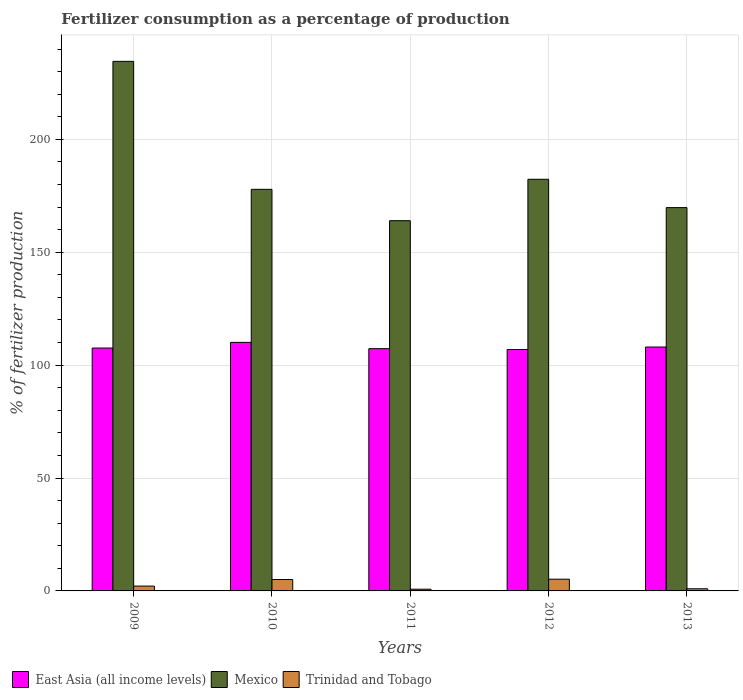How many different coloured bars are there?
Your response must be concise. 3. How many groups of bars are there?
Offer a very short reply. 5. Are the number of bars per tick equal to the number of legend labels?
Provide a short and direct response. Yes. Are the number of bars on each tick of the X-axis equal?
Your response must be concise. Yes. How many bars are there on the 4th tick from the left?
Make the answer very short. 3. What is the label of the 1st group of bars from the left?
Offer a very short reply. 2009. In how many cases, is the number of bars for a given year not equal to the number of legend labels?
Offer a very short reply. 0. What is the percentage of fertilizers consumed in East Asia (all income levels) in 2011?
Your answer should be compact. 107.3. Across all years, what is the maximum percentage of fertilizers consumed in Mexico?
Give a very brief answer. 234.56. Across all years, what is the minimum percentage of fertilizers consumed in Trinidad and Tobago?
Give a very brief answer. 0.76. In which year was the percentage of fertilizers consumed in Trinidad and Tobago maximum?
Provide a short and direct response. 2012. What is the total percentage of fertilizers consumed in Mexico in the graph?
Your answer should be very brief. 928.52. What is the difference between the percentage of fertilizers consumed in East Asia (all income levels) in 2011 and that in 2012?
Give a very brief answer. 0.38. What is the difference between the percentage of fertilizers consumed in Trinidad and Tobago in 2010 and the percentage of fertilizers consumed in Mexico in 2009?
Provide a short and direct response. -229.5. What is the average percentage of fertilizers consumed in Trinidad and Tobago per year?
Give a very brief answer. 2.82. In the year 2013, what is the difference between the percentage of fertilizers consumed in Trinidad and Tobago and percentage of fertilizers consumed in Mexico?
Give a very brief answer. -168.82. What is the ratio of the percentage of fertilizers consumed in Trinidad and Tobago in 2011 to that in 2012?
Your answer should be compact. 0.15. Is the percentage of fertilizers consumed in East Asia (all income levels) in 2010 less than that in 2012?
Provide a short and direct response. No. Is the difference between the percentage of fertilizers consumed in Trinidad and Tobago in 2010 and 2012 greater than the difference between the percentage of fertilizers consumed in Mexico in 2010 and 2012?
Make the answer very short. Yes. What is the difference between the highest and the second highest percentage of fertilizers consumed in Mexico?
Provide a short and direct response. 52.23. What is the difference between the highest and the lowest percentage of fertilizers consumed in Trinidad and Tobago?
Make the answer very short. 4.44. In how many years, is the percentage of fertilizers consumed in East Asia (all income levels) greater than the average percentage of fertilizers consumed in East Asia (all income levels) taken over all years?
Provide a succinct answer. 2. What does the 3rd bar from the left in 2012 represents?
Your response must be concise. Trinidad and Tobago. What does the 3rd bar from the right in 2010 represents?
Your answer should be very brief. East Asia (all income levels). Is it the case that in every year, the sum of the percentage of fertilizers consumed in East Asia (all income levels) and percentage of fertilizers consumed in Trinidad and Tobago is greater than the percentage of fertilizers consumed in Mexico?
Your answer should be very brief. No. Are all the bars in the graph horizontal?
Give a very brief answer. No. How many years are there in the graph?
Offer a terse response. 5. What is the difference between two consecutive major ticks on the Y-axis?
Your response must be concise. 50. Are the values on the major ticks of Y-axis written in scientific E-notation?
Offer a very short reply. No. Does the graph contain grids?
Provide a succinct answer. Yes. Where does the legend appear in the graph?
Your answer should be very brief. Bottom left. How many legend labels are there?
Keep it short and to the point. 3. What is the title of the graph?
Provide a succinct answer. Fertilizer consumption as a percentage of production. Does "St. Lucia" appear as one of the legend labels in the graph?
Your response must be concise. No. What is the label or title of the X-axis?
Your response must be concise. Years. What is the label or title of the Y-axis?
Offer a terse response. % of fertilizer production. What is the % of fertilizer production of East Asia (all income levels) in 2009?
Offer a terse response. 107.58. What is the % of fertilizer production in Mexico in 2009?
Provide a succinct answer. 234.56. What is the % of fertilizer production of Trinidad and Tobago in 2009?
Ensure brevity in your answer.  2.14. What is the % of fertilizer production in East Asia (all income levels) in 2010?
Your answer should be very brief. 110.09. What is the % of fertilizer production in Mexico in 2010?
Ensure brevity in your answer.  177.87. What is the % of fertilizer production in Trinidad and Tobago in 2010?
Your response must be concise. 5.06. What is the % of fertilizer production of East Asia (all income levels) in 2011?
Offer a very short reply. 107.3. What is the % of fertilizer production in Mexico in 2011?
Make the answer very short. 163.98. What is the % of fertilizer production of Trinidad and Tobago in 2011?
Your answer should be compact. 0.76. What is the % of fertilizer production of East Asia (all income levels) in 2012?
Your answer should be compact. 106.93. What is the % of fertilizer production of Mexico in 2012?
Ensure brevity in your answer.  182.33. What is the % of fertilizer production of Trinidad and Tobago in 2012?
Offer a terse response. 5.2. What is the % of fertilizer production of East Asia (all income levels) in 2013?
Ensure brevity in your answer.  108.03. What is the % of fertilizer production in Mexico in 2013?
Ensure brevity in your answer.  169.77. What is the % of fertilizer production in Trinidad and Tobago in 2013?
Keep it short and to the point. 0.95. Across all years, what is the maximum % of fertilizer production of East Asia (all income levels)?
Provide a succinct answer. 110.09. Across all years, what is the maximum % of fertilizer production in Mexico?
Make the answer very short. 234.56. Across all years, what is the maximum % of fertilizer production of Trinidad and Tobago?
Your response must be concise. 5.2. Across all years, what is the minimum % of fertilizer production in East Asia (all income levels)?
Provide a short and direct response. 106.93. Across all years, what is the minimum % of fertilizer production of Mexico?
Make the answer very short. 163.98. Across all years, what is the minimum % of fertilizer production in Trinidad and Tobago?
Keep it short and to the point. 0.76. What is the total % of fertilizer production of East Asia (all income levels) in the graph?
Give a very brief answer. 539.92. What is the total % of fertilizer production in Mexico in the graph?
Ensure brevity in your answer.  928.52. What is the total % of fertilizer production of Trinidad and Tobago in the graph?
Provide a succinct answer. 14.11. What is the difference between the % of fertilizer production of East Asia (all income levels) in 2009 and that in 2010?
Offer a very short reply. -2.51. What is the difference between the % of fertilizer production in Mexico in 2009 and that in 2010?
Your answer should be very brief. 56.68. What is the difference between the % of fertilizer production in Trinidad and Tobago in 2009 and that in 2010?
Ensure brevity in your answer.  -2.91. What is the difference between the % of fertilizer production in East Asia (all income levels) in 2009 and that in 2011?
Ensure brevity in your answer.  0.27. What is the difference between the % of fertilizer production in Mexico in 2009 and that in 2011?
Offer a very short reply. 70.58. What is the difference between the % of fertilizer production in Trinidad and Tobago in 2009 and that in 2011?
Ensure brevity in your answer.  1.38. What is the difference between the % of fertilizer production of East Asia (all income levels) in 2009 and that in 2012?
Offer a terse response. 0.65. What is the difference between the % of fertilizer production of Mexico in 2009 and that in 2012?
Keep it short and to the point. 52.23. What is the difference between the % of fertilizer production in Trinidad and Tobago in 2009 and that in 2012?
Offer a terse response. -3.05. What is the difference between the % of fertilizer production of East Asia (all income levels) in 2009 and that in 2013?
Your answer should be compact. -0.45. What is the difference between the % of fertilizer production in Mexico in 2009 and that in 2013?
Your answer should be very brief. 64.78. What is the difference between the % of fertilizer production in Trinidad and Tobago in 2009 and that in 2013?
Make the answer very short. 1.19. What is the difference between the % of fertilizer production in East Asia (all income levels) in 2010 and that in 2011?
Keep it short and to the point. 2.78. What is the difference between the % of fertilizer production of Mexico in 2010 and that in 2011?
Make the answer very short. 13.89. What is the difference between the % of fertilizer production in Trinidad and Tobago in 2010 and that in 2011?
Your response must be concise. 4.3. What is the difference between the % of fertilizer production of East Asia (all income levels) in 2010 and that in 2012?
Your answer should be compact. 3.16. What is the difference between the % of fertilizer production of Mexico in 2010 and that in 2012?
Ensure brevity in your answer.  -4.46. What is the difference between the % of fertilizer production in Trinidad and Tobago in 2010 and that in 2012?
Your answer should be compact. -0.14. What is the difference between the % of fertilizer production in East Asia (all income levels) in 2010 and that in 2013?
Your answer should be very brief. 2.06. What is the difference between the % of fertilizer production of Mexico in 2010 and that in 2013?
Offer a terse response. 8.1. What is the difference between the % of fertilizer production in Trinidad and Tobago in 2010 and that in 2013?
Keep it short and to the point. 4.1. What is the difference between the % of fertilizer production of East Asia (all income levels) in 2011 and that in 2012?
Your response must be concise. 0.38. What is the difference between the % of fertilizer production of Mexico in 2011 and that in 2012?
Offer a terse response. -18.35. What is the difference between the % of fertilizer production in Trinidad and Tobago in 2011 and that in 2012?
Offer a terse response. -4.44. What is the difference between the % of fertilizer production of East Asia (all income levels) in 2011 and that in 2013?
Your answer should be compact. -0.72. What is the difference between the % of fertilizer production in Mexico in 2011 and that in 2013?
Provide a succinct answer. -5.79. What is the difference between the % of fertilizer production of Trinidad and Tobago in 2011 and that in 2013?
Your response must be concise. -0.19. What is the difference between the % of fertilizer production of East Asia (all income levels) in 2012 and that in 2013?
Offer a very short reply. -1.1. What is the difference between the % of fertilizer production in Mexico in 2012 and that in 2013?
Offer a very short reply. 12.56. What is the difference between the % of fertilizer production of Trinidad and Tobago in 2012 and that in 2013?
Offer a terse response. 4.24. What is the difference between the % of fertilizer production of East Asia (all income levels) in 2009 and the % of fertilizer production of Mexico in 2010?
Keep it short and to the point. -70.3. What is the difference between the % of fertilizer production of East Asia (all income levels) in 2009 and the % of fertilizer production of Trinidad and Tobago in 2010?
Offer a very short reply. 102.52. What is the difference between the % of fertilizer production in Mexico in 2009 and the % of fertilizer production in Trinidad and Tobago in 2010?
Offer a terse response. 229.5. What is the difference between the % of fertilizer production in East Asia (all income levels) in 2009 and the % of fertilizer production in Mexico in 2011?
Your answer should be compact. -56.4. What is the difference between the % of fertilizer production of East Asia (all income levels) in 2009 and the % of fertilizer production of Trinidad and Tobago in 2011?
Offer a terse response. 106.81. What is the difference between the % of fertilizer production of Mexico in 2009 and the % of fertilizer production of Trinidad and Tobago in 2011?
Provide a succinct answer. 233.8. What is the difference between the % of fertilizer production in East Asia (all income levels) in 2009 and the % of fertilizer production in Mexico in 2012?
Make the answer very short. -74.75. What is the difference between the % of fertilizer production of East Asia (all income levels) in 2009 and the % of fertilizer production of Trinidad and Tobago in 2012?
Make the answer very short. 102.38. What is the difference between the % of fertilizer production in Mexico in 2009 and the % of fertilizer production in Trinidad and Tobago in 2012?
Your response must be concise. 229.36. What is the difference between the % of fertilizer production in East Asia (all income levels) in 2009 and the % of fertilizer production in Mexico in 2013?
Provide a short and direct response. -62.2. What is the difference between the % of fertilizer production in East Asia (all income levels) in 2009 and the % of fertilizer production in Trinidad and Tobago in 2013?
Ensure brevity in your answer.  106.62. What is the difference between the % of fertilizer production of Mexico in 2009 and the % of fertilizer production of Trinidad and Tobago in 2013?
Your answer should be compact. 233.6. What is the difference between the % of fertilizer production of East Asia (all income levels) in 2010 and the % of fertilizer production of Mexico in 2011?
Keep it short and to the point. -53.89. What is the difference between the % of fertilizer production in East Asia (all income levels) in 2010 and the % of fertilizer production in Trinidad and Tobago in 2011?
Your response must be concise. 109.33. What is the difference between the % of fertilizer production of Mexico in 2010 and the % of fertilizer production of Trinidad and Tobago in 2011?
Provide a short and direct response. 177.11. What is the difference between the % of fertilizer production of East Asia (all income levels) in 2010 and the % of fertilizer production of Mexico in 2012?
Keep it short and to the point. -72.24. What is the difference between the % of fertilizer production in East Asia (all income levels) in 2010 and the % of fertilizer production in Trinidad and Tobago in 2012?
Offer a very short reply. 104.89. What is the difference between the % of fertilizer production of Mexico in 2010 and the % of fertilizer production of Trinidad and Tobago in 2012?
Give a very brief answer. 172.68. What is the difference between the % of fertilizer production in East Asia (all income levels) in 2010 and the % of fertilizer production in Mexico in 2013?
Offer a terse response. -59.69. What is the difference between the % of fertilizer production in East Asia (all income levels) in 2010 and the % of fertilizer production in Trinidad and Tobago in 2013?
Provide a short and direct response. 109.13. What is the difference between the % of fertilizer production of Mexico in 2010 and the % of fertilizer production of Trinidad and Tobago in 2013?
Offer a very short reply. 176.92. What is the difference between the % of fertilizer production of East Asia (all income levels) in 2011 and the % of fertilizer production of Mexico in 2012?
Provide a short and direct response. -75.03. What is the difference between the % of fertilizer production in East Asia (all income levels) in 2011 and the % of fertilizer production in Trinidad and Tobago in 2012?
Offer a terse response. 102.11. What is the difference between the % of fertilizer production in Mexico in 2011 and the % of fertilizer production in Trinidad and Tobago in 2012?
Make the answer very short. 158.78. What is the difference between the % of fertilizer production of East Asia (all income levels) in 2011 and the % of fertilizer production of Mexico in 2013?
Ensure brevity in your answer.  -62.47. What is the difference between the % of fertilizer production in East Asia (all income levels) in 2011 and the % of fertilizer production in Trinidad and Tobago in 2013?
Offer a terse response. 106.35. What is the difference between the % of fertilizer production of Mexico in 2011 and the % of fertilizer production of Trinidad and Tobago in 2013?
Ensure brevity in your answer.  163.03. What is the difference between the % of fertilizer production in East Asia (all income levels) in 2012 and the % of fertilizer production in Mexico in 2013?
Offer a terse response. -62.85. What is the difference between the % of fertilizer production in East Asia (all income levels) in 2012 and the % of fertilizer production in Trinidad and Tobago in 2013?
Give a very brief answer. 105.97. What is the difference between the % of fertilizer production of Mexico in 2012 and the % of fertilizer production of Trinidad and Tobago in 2013?
Your answer should be very brief. 181.38. What is the average % of fertilizer production of East Asia (all income levels) per year?
Provide a short and direct response. 107.98. What is the average % of fertilizer production of Mexico per year?
Provide a short and direct response. 185.7. What is the average % of fertilizer production of Trinidad and Tobago per year?
Ensure brevity in your answer.  2.82. In the year 2009, what is the difference between the % of fertilizer production in East Asia (all income levels) and % of fertilizer production in Mexico?
Provide a succinct answer. -126.98. In the year 2009, what is the difference between the % of fertilizer production of East Asia (all income levels) and % of fertilizer production of Trinidad and Tobago?
Give a very brief answer. 105.43. In the year 2009, what is the difference between the % of fertilizer production in Mexico and % of fertilizer production in Trinidad and Tobago?
Give a very brief answer. 232.41. In the year 2010, what is the difference between the % of fertilizer production in East Asia (all income levels) and % of fertilizer production in Mexico?
Your answer should be compact. -67.79. In the year 2010, what is the difference between the % of fertilizer production in East Asia (all income levels) and % of fertilizer production in Trinidad and Tobago?
Offer a very short reply. 105.03. In the year 2010, what is the difference between the % of fertilizer production in Mexico and % of fertilizer production in Trinidad and Tobago?
Keep it short and to the point. 172.82. In the year 2011, what is the difference between the % of fertilizer production in East Asia (all income levels) and % of fertilizer production in Mexico?
Keep it short and to the point. -56.68. In the year 2011, what is the difference between the % of fertilizer production of East Asia (all income levels) and % of fertilizer production of Trinidad and Tobago?
Ensure brevity in your answer.  106.54. In the year 2011, what is the difference between the % of fertilizer production of Mexico and % of fertilizer production of Trinidad and Tobago?
Keep it short and to the point. 163.22. In the year 2012, what is the difference between the % of fertilizer production in East Asia (all income levels) and % of fertilizer production in Mexico?
Offer a very short reply. -75.4. In the year 2012, what is the difference between the % of fertilizer production in East Asia (all income levels) and % of fertilizer production in Trinidad and Tobago?
Offer a terse response. 101.73. In the year 2012, what is the difference between the % of fertilizer production of Mexico and % of fertilizer production of Trinidad and Tobago?
Offer a very short reply. 177.13. In the year 2013, what is the difference between the % of fertilizer production of East Asia (all income levels) and % of fertilizer production of Mexico?
Give a very brief answer. -61.75. In the year 2013, what is the difference between the % of fertilizer production in East Asia (all income levels) and % of fertilizer production in Trinidad and Tobago?
Your answer should be compact. 107.07. In the year 2013, what is the difference between the % of fertilizer production of Mexico and % of fertilizer production of Trinidad and Tobago?
Offer a terse response. 168.82. What is the ratio of the % of fertilizer production in East Asia (all income levels) in 2009 to that in 2010?
Make the answer very short. 0.98. What is the ratio of the % of fertilizer production of Mexico in 2009 to that in 2010?
Your answer should be compact. 1.32. What is the ratio of the % of fertilizer production of Trinidad and Tobago in 2009 to that in 2010?
Give a very brief answer. 0.42. What is the ratio of the % of fertilizer production in East Asia (all income levels) in 2009 to that in 2011?
Provide a short and direct response. 1. What is the ratio of the % of fertilizer production of Mexico in 2009 to that in 2011?
Your response must be concise. 1.43. What is the ratio of the % of fertilizer production in Trinidad and Tobago in 2009 to that in 2011?
Offer a very short reply. 2.82. What is the ratio of the % of fertilizer production in East Asia (all income levels) in 2009 to that in 2012?
Offer a terse response. 1.01. What is the ratio of the % of fertilizer production of Mexico in 2009 to that in 2012?
Provide a short and direct response. 1.29. What is the ratio of the % of fertilizer production in Trinidad and Tobago in 2009 to that in 2012?
Ensure brevity in your answer.  0.41. What is the ratio of the % of fertilizer production in Mexico in 2009 to that in 2013?
Keep it short and to the point. 1.38. What is the ratio of the % of fertilizer production in Trinidad and Tobago in 2009 to that in 2013?
Your response must be concise. 2.25. What is the ratio of the % of fertilizer production in East Asia (all income levels) in 2010 to that in 2011?
Keep it short and to the point. 1.03. What is the ratio of the % of fertilizer production in Mexico in 2010 to that in 2011?
Your answer should be compact. 1.08. What is the ratio of the % of fertilizer production in Trinidad and Tobago in 2010 to that in 2011?
Your response must be concise. 6.65. What is the ratio of the % of fertilizer production of East Asia (all income levels) in 2010 to that in 2012?
Make the answer very short. 1.03. What is the ratio of the % of fertilizer production in Mexico in 2010 to that in 2012?
Make the answer very short. 0.98. What is the ratio of the % of fertilizer production of Trinidad and Tobago in 2010 to that in 2012?
Your response must be concise. 0.97. What is the ratio of the % of fertilizer production of East Asia (all income levels) in 2010 to that in 2013?
Your answer should be compact. 1.02. What is the ratio of the % of fertilizer production in Mexico in 2010 to that in 2013?
Your response must be concise. 1.05. What is the ratio of the % of fertilizer production in Trinidad and Tobago in 2010 to that in 2013?
Your answer should be very brief. 5.3. What is the ratio of the % of fertilizer production in East Asia (all income levels) in 2011 to that in 2012?
Make the answer very short. 1. What is the ratio of the % of fertilizer production of Mexico in 2011 to that in 2012?
Your answer should be very brief. 0.9. What is the ratio of the % of fertilizer production of Trinidad and Tobago in 2011 to that in 2012?
Give a very brief answer. 0.15. What is the ratio of the % of fertilizer production of East Asia (all income levels) in 2011 to that in 2013?
Offer a very short reply. 0.99. What is the ratio of the % of fertilizer production of Mexico in 2011 to that in 2013?
Make the answer very short. 0.97. What is the ratio of the % of fertilizer production in Trinidad and Tobago in 2011 to that in 2013?
Make the answer very short. 0.8. What is the ratio of the % of fertilizer production in Mexico in 2012 to that in 2013?
Provide a succinct answer. 1.07. What is the ratio of the % of fertilizer production of Trinidad and Tobago in 2012 to that in 2013?
Keep it short and to the point. 5.44. What is the difference between the highest and the second highest % of fertilizer production in East Asia (all income levels)?
Your response must be concise. 2.06. What is the difference between the highest and the second highest % of fertilizer production of Mexico?
Give a very brief answer. 52.23. What is the difference between the highest and the second highest % of fertilizer production of Trinidad and Tobago?
Ensure brevity in your answer.  0.14. What is the difference between the highest and the lowest % of fertilizer production of East Asia (all income levels)?
Make the answer very short. 3.16. What is the difference between the highest and the lowest % of fertilizer production in Mexico?
Keep it short and to the point. 70.58. What is the difference between the highest and the lowest % of fertilizer production in Trinidad and Tobago?
Your response must be concise. 4.44. 